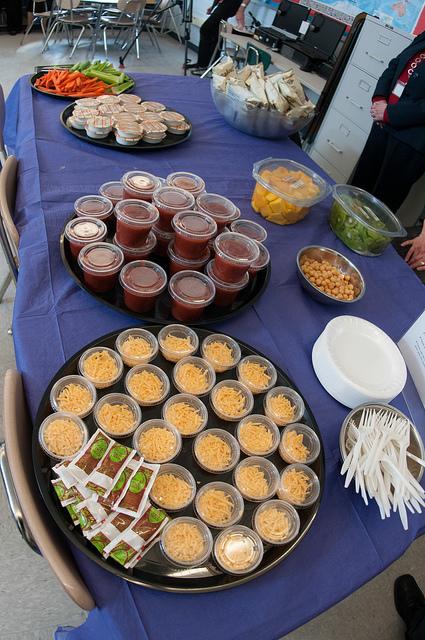What is in the cups?
Be succinct. Cheese. Is this healthy food?
Give a very brief answer. Yes. What utensil is shown?
Answer briefly. Forks. 